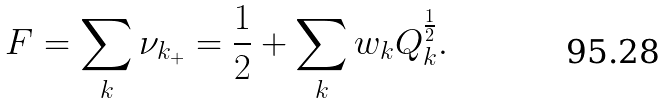<formula> <loc_0><loc_0><loc_500><loc_500>F = \sum _ { k } \nu _ { k _ { + } } = \frac { 1 } { 2 } + \sum _ { k } w _ { k } Q _ { k } ^ { \frac { 1 } { 2 } } .</formula> 